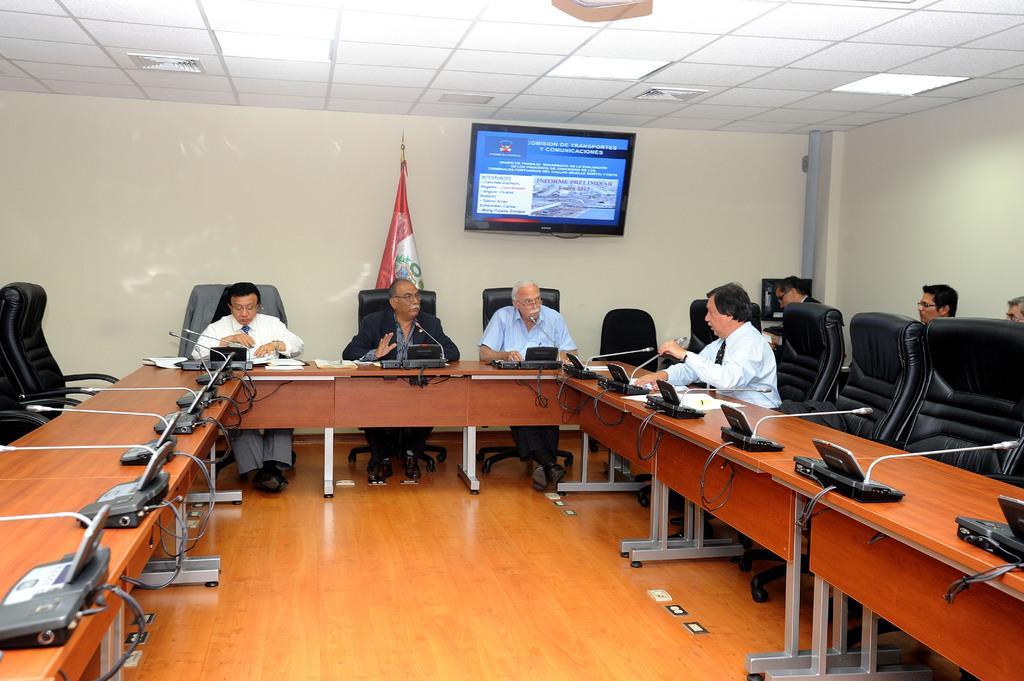Can you describe this image briefly? In this image we can see group of people some are standing and some are seated on the chairs in a room we can see microphones and telephones in front of them on the tables in the background we can see television. 